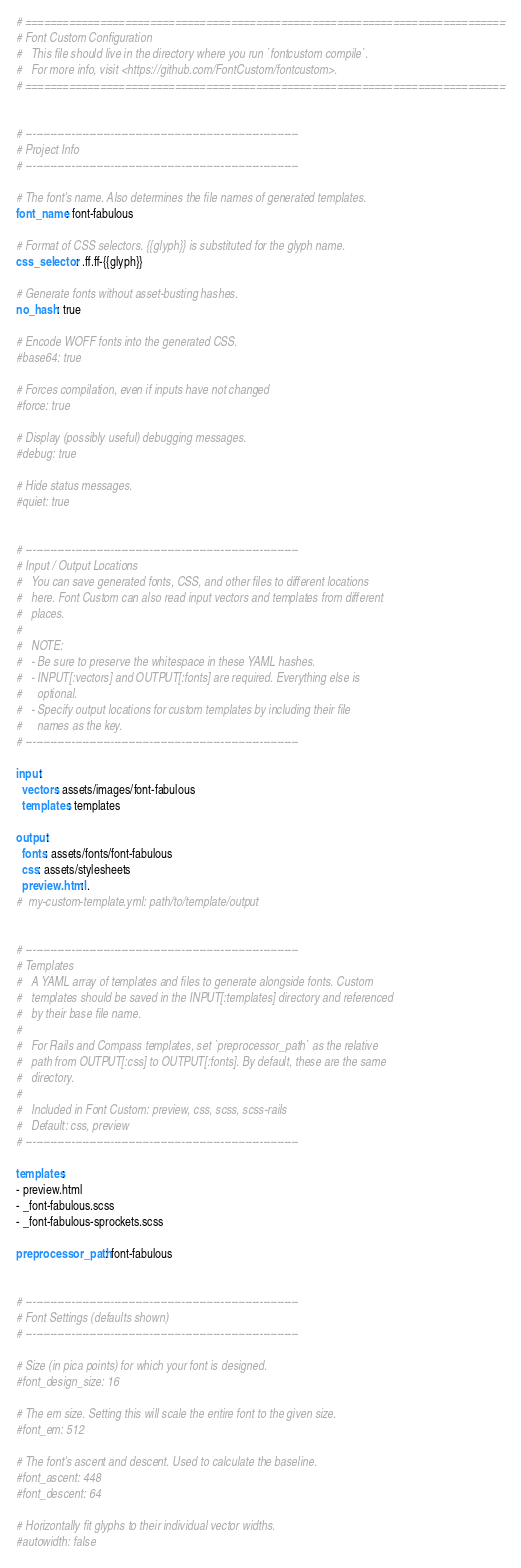Convert code to text. <code><loc_0><loc_0><loc_500><loc_500><_YAML_># =============================================================================
# Font Custom Configuration
#   This file should live in the directory where you run `fontcustom compile`.
#   For more info, visit <https://github.com/FontCustom/fontcustom>.
# =============================================================================


# -----------------------------------------------------------------------------
# Project Info
# -----------------------------------------------------------------------------

# The font's name. Also determines the file names of generated templates.
font_name: font-fabulous

# Format of CSS selectors. {{glyph}} is substituted for the glyph name.
css_selector: .ff.ff-{{glyph}}

# Generate fonts without asset-busting hashes.
no_hash: true

# Encode WOFF fonts into the generated CSS.
#base64: true

# Forces compilation, even if inputs have not changed
#force: true

# Display (possibly useful) debugging messages.
#debug: true

# Hide status messages.
#quiet: true


# -----------------------------------------------------------------------------
# Input / Output Locations
#   You can save generated fonts, CSS, and other files to different locations
#   here. Font Custom can also read input vectors and templates from different
#   places.
#
#   NOTE:
#   - Be sure to preserve the whitespace in these YAML hashes.
#   - INPUT[:vectors] and OUTPUT[:fonts] are required. Everything else is
#     optional.
#   - Specify output locations for custom templates by including their file
#     names as the key.
# -----------------------------------------------------------------------------

input:
  vectors: assets/images/font-fabulous
  templates: templates

output:
  fonts: assets/fonts/font-fabulous
  css: assets/stylesheets
  preview.html: .
#  my-custom-template.yml: path/to/template/output


# -----------------------------------------------------------------------------
# Templates
#   A YAML array of templates and files to generate alongside fonts. Custom
#   templates should be saved in the INPUT[:templates] directory and referenced
#   by their base file name.
#
#   For Rails and Compass templates, set `preprocessor_path` as the relative
#   path from OUTPUT[:css] to OUTPUT[:fonts]. By default, these are the same
#   directory.
#
#   Included in Font Custom: preview, css, scss, scss-rails
#   Default: css, preview
# -----------------------------------------------------------------------------

templates:
- preview.html
- _font-fabulous.scss
- _font-fabulous-sprockets.scss

preprocessor_path: font-fabulous


# -----------------------------------------------------------------------------
# Font Settings (defaults shown)
# -----------------------------------------------------------------------------

# Size (in pica points) for which your font is designed.
#font_design_size: 16

# The em size. Setting this will scale the entire font to the given size.
#font_em: 512

# The font's ascent and descent. Used to calculate the baseline.
#font_ascent: 448
#font_descent: 64

# Horizontally fit glyphs to their individual vector widths.
#autowidth: false
</code> 